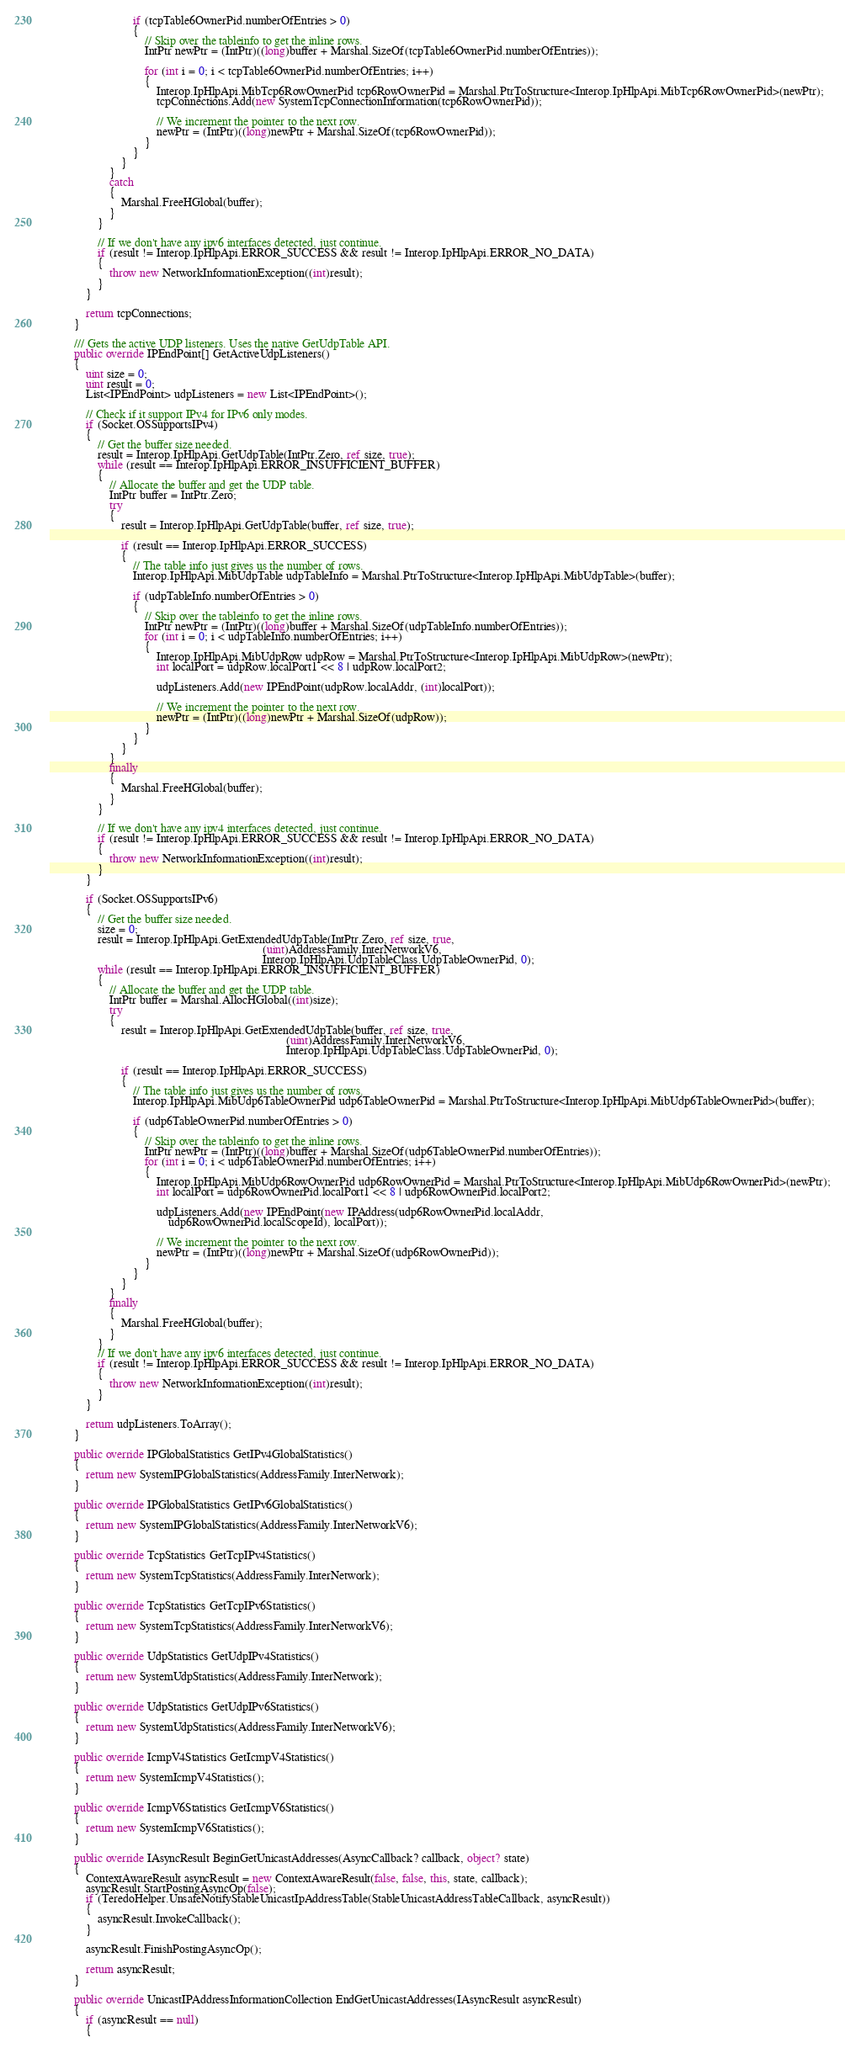Convert code to text. <code><loc_0><loc_0><loc_500><loc_500><_C#_>                            if (tcpTable6OwnerPid.numberOfEntries > 0)
                            {
                                // Skip over the tableinfo to get the inline rows.
                                IntPtr newPtr = (IntPtr)((long)buffer + Marshal.SizeOf(tcpTable6OwnerPid.numberOfEntries));

                                for (int i = 0; i < tcpTable6OwnerPid.numberOfEntries; i++)
                                {
                                    Interop.IpHlpApi.MibTcp6RowOwnerPid tcp6RowOwnerPid = Marshal.PtrToStructure<Interop.IpHlpApi.MibTcp6RowOwnerPid>(newPtr);
                                    tcpConnections.Add(new SystemTcpConnectionInformation(tcp6RowOwnerPid));

                                    // We increment the pointer to the next row.
                                    newPtr = (IntPtr)((long)newPtr + Marshal.SizeOf(tcp6RowOwnerPid));
                                }
                            }
                        }
                    }
                    catch
                    {
                        Marshal.FreeHGlobal(buffer);
                    }
                }

                // If we don't have any ipv6 interfaces detected, just continue.
                if (result != Interop.IpHlpApi.ERROR_SUCCESS && result != Interop.IpHlpApi.ERROR_NO_DATA)
                {
                    throw new NetworkInformationException((int)result);
                }
            }

            return tcpConnections;
        }

        /// Gets the active UDP listeners. Uses the native GetUdpTable API.
        public override IPEndPoint[] GetActiveUdpListeners()
        {
            uint size = 0;
            uint result = 0;
            List<IPEndPoint> udpListeners = new List<IPEndPoint>();

            // Check if it support IPv4 for IPv6 only modes.
            if (Socket.OSSupportsIPv4)
            {
                // Get the buffer size needed.
                result = Interop.IpHlpApi.GetUdpTable(IntPtr.Zero, ref size, true);
                while (result == Interop.IpHlpApi.ERROR_INSUFFICIENT_BUFFER)
                {
                    // Allocate the buffer and get the UDP table.
                    IntPtr buffer = IntPtr.Zero;
                    try
                    {
                        result = Interop.IpHlpApi.GetUdpTable(buffer, ref size, true);

                        if (result == Interop.IpHlpApi.ERROR_SUCCESS)
                        {
                            // The table info just gives us the number of rows.
                            Interop.IpHlpApi.MibUdpTable udpTableInfo = Marshal.PtrToStructure<Interop.IpHlpApi.MibUdpTable>(buffer);

                            if (udpTableInfo.numberOfEntries > 0)
                            {
                                // Skip over the tableinfo to get the inline rows.
                                IntPtr newPtr = (IntPtr)((long)buffer + Marshal.SizeOf(udpTableInfo.numberOfEntries));
                                for (int i = 0; i < udpTableInfo.numberOfEntries; i++)
                                {
                                    Interop.IpHlpApi.MibUdpRow udpRow = Marshal.PtrToStructure<Interop.IpHlpApi.MibUdpRow>(newPtr);
                                    int localPort = udpRow.localPort1 << 8 | udpRow.localPort2;

                                    udpListeners.Add(new IPEndPoint(udpRow.localAddr, (int)localPort));

                                    // We increment the pointer to the next row.
                                    newPtr = (IntPtr)((long)newPtr + Marshal.SizeOf(udpRow));
                                }
                            }
                        }
                    }
                    finally
                    {
                        Marshal.FreeHGlobal(buffer);
                    }
                }

                // If we don't have any ipv4 interfaces detected, just continue.
                if (result != Interop.IpHlpApi.ERROR_SUCCESS && result != Interop.IpHlpApi.ERROR_NO_DATA)
                {
                    throw new NetworkInformationException((int)result);
                }
            }

            if (Socket.OSSupportsIPv6)
            {
                // Get the buffer size needed.
                size = 0;
                result = Interop.IpHlpApi.GetExtendedUdpTable(IntPtr.Zero, ref size, true,
                                                                        (uint)AddressFamily.InterNetworkV6,
                                                                        Interop.IpHlpApi.UdpTableClass.UdpTableOwnerPid, 0);
                while (result == Interop.IpHlpApi.ERROR_INSUFFICIENT_BUFFER)
                {
                    // Allocate the buffer and get the UDP table.
                    IntPtr buffer = Marshal.AllocHGlobal((int)size);
                    try
                    {
                        result = Interop.IpHlpApi.GetExtendedUdpTable(buffer, ref size, true,
                                                                                (uint)AddressFamily.InterNetworkV6,
                                                                                Interop.IpHlpApi.UdpTableClass.UdpTableOwnerPid, 0);

                        if (result == Interop.IpHlpApi.ERROR_SUCCESS)
                        {
                            // The table info just gives us the number of rows.
                            Interop.IpHlpApi.MibUdp6TableOwnerPid udp6TableOwnerPid = Marshal.PtrToStructure<Interop.IpHlpApi.MibUdp6TableOwnerPid>(buffer);

                            if (udp6TableOwnerPid.numberOfEntries > 0)
                            {
                                // Skip over the tableinfo to get the inline rows.
                                IntPtr newPtr = (IntPtr)((long)buffer + Marshal.SizeOf(udp6TableOwnerPid.numberOfEntries));
                                for (int i = 0; i < udp6TableOwnerPid.numberOfEntries; i++)
                                {
                                    Interop.IpHlpApi.MibUdp6RowOwnerPid udp6RowOwnerPid = Marshal.PtrToStructure<Interop.IpHlpApi.MibUdp6RowOwnerPid>(newPtr);
                                    int localPort = udp6RowOwnerPid.localPort1 << 8 | udp6RowOwnerPid.localPort2;

                                    udpListeners.Add(new IPEndPoint(new IPAddress(udp6RowOwnerPid.localAddr,
                                        udp6RowOwnerPid.localScopeId), localPort));

                                    // We increment the pointer to the next row.
                                    newPtr = (IntPtr)((long)newPtr + Marshal.SizeOf(udp6RowOwnerPid));
                                }
                            }
                        }
                    }
                    finally
                    {
                        Marshal.FreeHGlobal(buffer);
                    }
                }
                // If we don't have any ipv6 interfaces detected, just continue.
                if (result != Interop.IpHlpApi.ERROR_SUCCESS && result != Interop.IpHlpApi.ERROR_NO_DATA)
                {
                    throw new NetworkInformationException((int)result);
                }
            }

            return udpListeners.ToArray();
        }

        public override IPGlobalStatistics GetIPv4GlobalStatistics()
        {
            return new SystemIPGlobalStatistics(AddressFamily.InterNetwork);
        }

        public override IPGlobalStatistics GetIPv6GlobalStatistics()
        {
            return new SystemIPGlobalStatistics(AddressFamily.InterNetworkV6);
        }

        public override TcpStatistics GetTcpIPv4Statistics()
        {
            return new SystemTcpStatistics(AddressFamily.InterNetwork);
        }

        public override TcpStatistics GetTcpIPv6Statistics()
        {
            return new SystemTcpStatistics(AddressFamily.InterNetworkV6);
        }

        public override UdpStatistics GetUdpIPv4Statistics()
        {
            return new SystemUdpStatistics(AddressFamily.InterNetwork);
        }

        public override UdpStatistics GetUdpIPv6Statistics()
        {
            return new SystemUdpStatistics(AddressFamily.InterNetworkV6);
        }

        public override IcmpV4Statistics GetIcmpV4Statistics()
        {
            return new SystemIcmpV4Statistics();
        }

        public override IcmpV6Statistics GetIcmpV6Statistics()
        {
            return new SystemIcmpV6Statistics();
        }

        public override IAsyncResult BeginGetUnicastAddresses(AsyncCallback? callback, object? state)
        {
            ContextAwareResult asyncResult = new ContextAwareResult(false, false, this, state, callback);
            asyncResult.StartPostingAsyncOp(false);
            if (TeredoHelper.UnsafeNotifyStableUnicastIpAddressTable(StableUnicastAddressTableCallback, asyncResult))
            {
                asyncResult.InvokeCallback();
            }

            asyncResult.FinishPostingAsyncOp();

            return asyncResult;
        }

        public override UnicastIPAddressInformationCollection EndGetUnicastAddresses(IAsyncResult asyncResult)
        {
            if (asyncResult == null)
            {</code> 